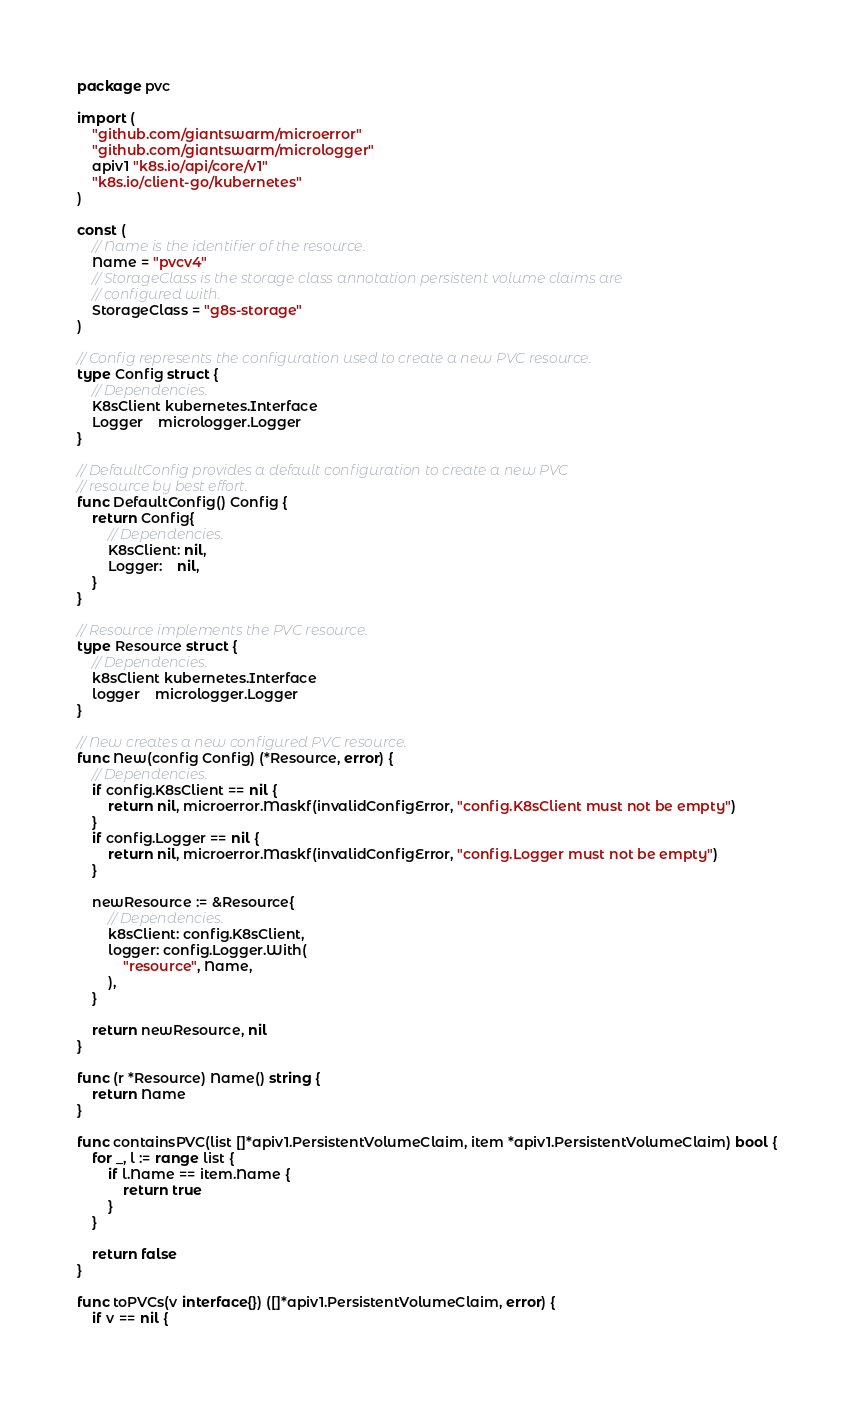<code> <loc_0><loc_0><loc_500><loc_500><_Go_>package pvc

import (
	"github.com/giantswarm/microerror"
	"github.com/giantswarm/micrologger"
	apiv1 "k8s.io/api/core/v1"
	"k8s.io/client-go/kubernetes"
)

const (
	// Name is the identifier of the resource.
	Name = "pvcv4"
	// StorageClass is the storage class annotation persistent volume claims are
	// configured with.
	StorageClass = "g8s-storage"
)

// Config represents the configuration used to create a new PVC resource.
type Config struct {
	// Dependencies.
	K8sClient kubernetes.Interface
	Logger    micrologger.Logger
}

// DefaultConfig provides a default configuration to create a new PVC
// resource by best effort.
func DefaultConfig() Config {
	return Config{
		// Dependencies.
		K8sClient: nil,
		Logger:    nil,
	}
}

// Resource implements the PVC resource.
type Resource struct {
	// Dependencies.
	k8sClient kubernetes.Interface
	logger    micrologger.Logger
}

// New creates a new configured PVC resource.
func New(config Config) (*Resource, error) {
	// Dependencies.
	if config.K8sClient == nil {
		return nil, microerror.Maskf(invalidConfigError, "config.K8sClient must not be empty")
	}
	if config.Logger == nil {
		return nil, microerror.Maskf(invalidConfigError, "config.Logger must not be empty")
	}

	newResource := &Resource{
		// Dependencies.
		k8sClient: config.K8sClient,
		logger: config.Logger.With(
			"resource", Name,
		),
	}

	return newResource, nil
}

func (r *Resource) Name() string {
	return Name
}

func containsPVC(list []*apiv1.PersistentVolumeClaim, item *apiv1.PersistentVolumeClaim) bool {
	for _, l := range list {
		if l.Name == item.Name {
			return true
		}
	}

	return false
}

func toPVCs(v interface{}) ([]*apiv1.PersistentVolumeClaim, error) {
	if v == nil {</code> 